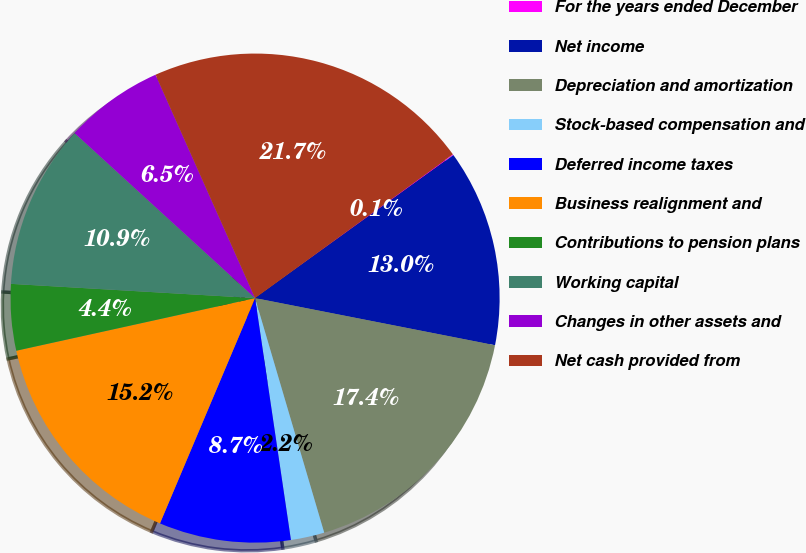Convert chart. <chart><loc_0><loc_0><loc_500><loc_500><pie_chart><fcel>For the years ended December<fcel>Net income<fcel>Depreciation and amortization<fcel>Stock-based compensation and<fcel>Deferred income taxes<fcel>Business realignment and<fcel>Contributions to pension plans<fcel>Working capital<fcel>Changes in other assets and<fcel>Net cash provided from<nl><fcel>0.06%<fcel>13.03%<fcel>17.35%<fcel>2.22%<fcel>8.7%<fcel>15.19%<fcel>4.38%<fcel>10.86%<fcel>6.54%<fcel>21.67%<nl></chart> 